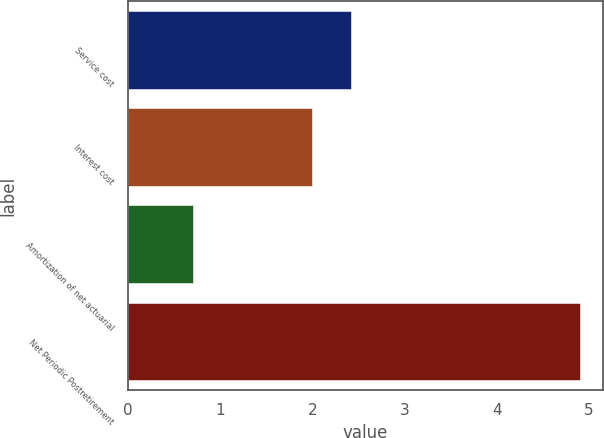<chart> <loc_0><loc_0><loc_500><loc_500><bar_chart><fcel>Service cost<fcel>Interest cost<fcel>Amortization of net actuarial<fcel>Net Periodic Postretirement<nl><fcel>2.42<fcel>2<fcel>0.7<fcel>4.9<nl></chart> 